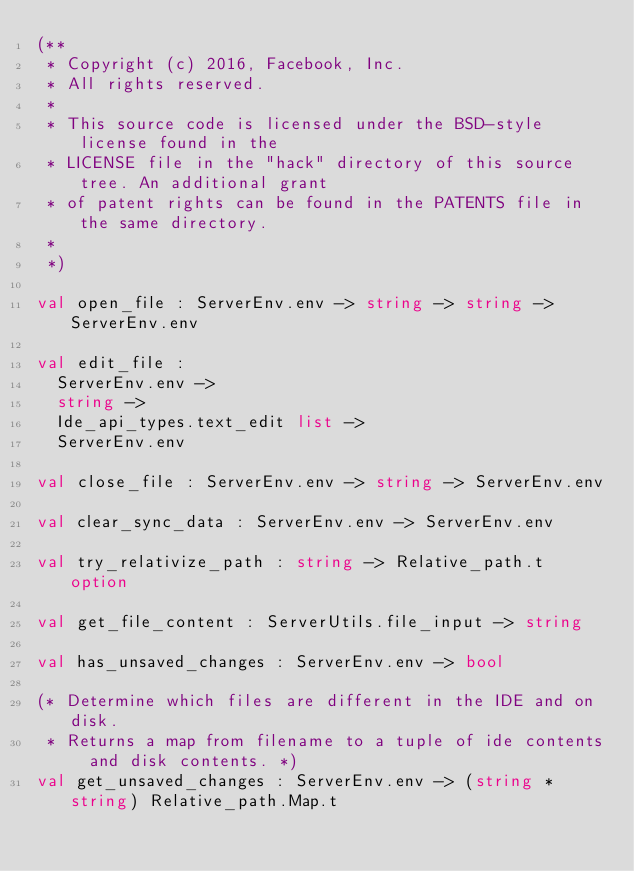Convert code to text. <code><loc_0><loc_0><loc_500><loc_500><_OCaml_>(**
 * Copyright (c) 2016, Facebook, Inc.
 * All rights reserved.
 *
 * This source code is licensed under the BSD-style license found in the
 * LICENSE file in the "hack" directory of this source tree. An additional grant
 * of patent rights can be found in the PATENTS file in the same directory.
 *
 *)

val open_file : ServerEnv.env -> string -> string -> ServerEnv.env

val edit_file :
  ServerEnv.env ->
  string ->
  Ide_api_types.text_edit list ->
  ServerEnv.env

val close_file : ServerEnv.env -> string -> ServerEnv.env

val clear_sync_data : ServerEnv.env -> ServerEnv.env

val try_relativize_path : string -> Relative_path.t option

val get_file_content : ServerUtils.file_input -> string

val has_unsaved_changes : ServerEnv.env -> bool

(* Determine which files are different in the IDE and on disk.
 * Returns a map from filename to a tuple of ide contents and disk contents. *)
val get_unsaved_changes : ServerEnv.env -> (string * string) Relative_path.Map.t
</code> 